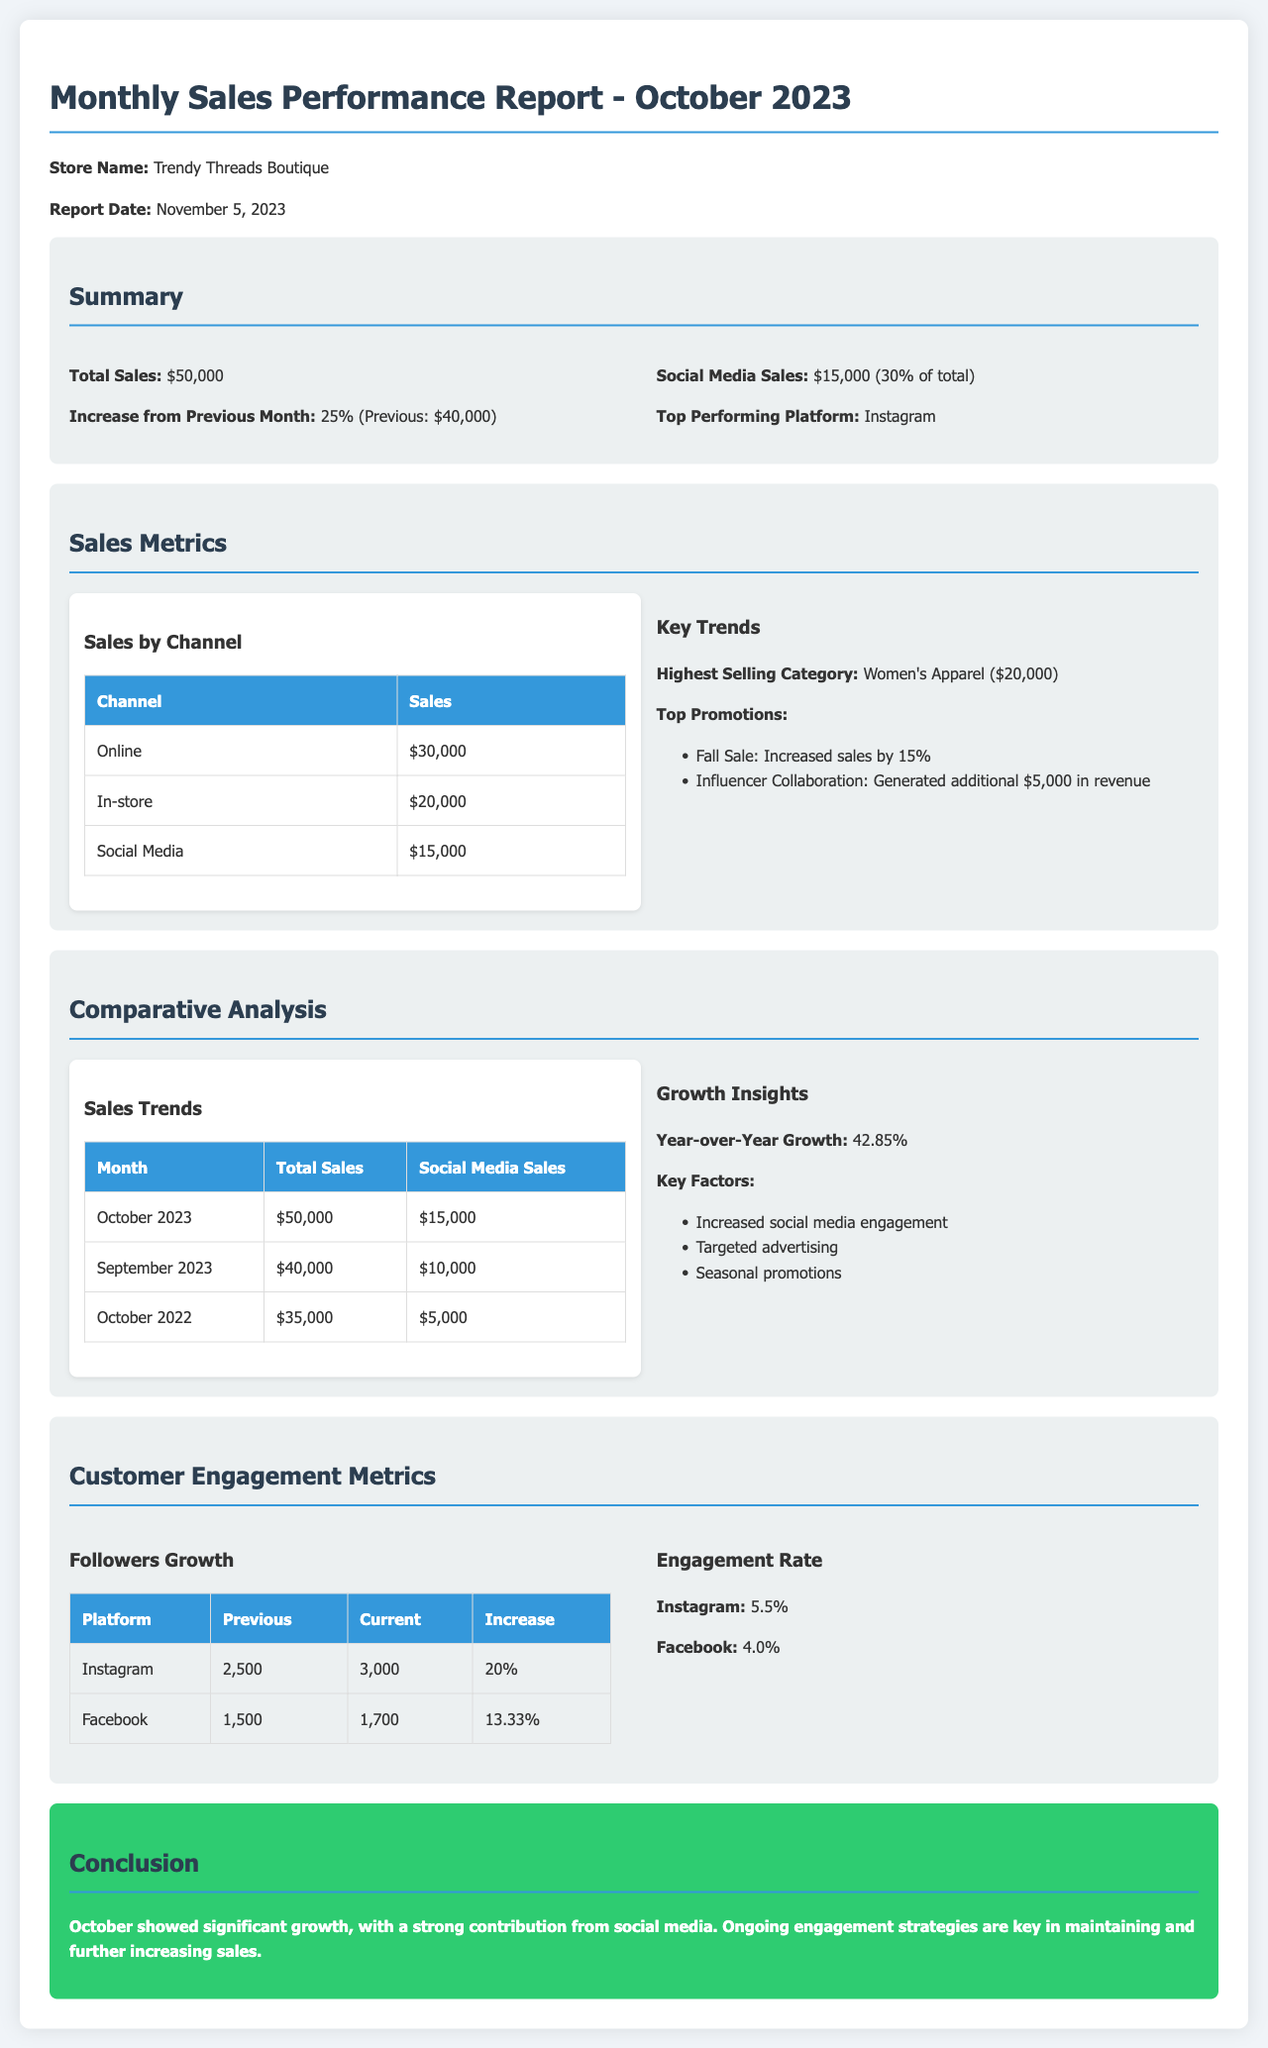what is the total sales for October 2023? The total sales are explicitly stated in the summary section as $50,000.
Answer: $50,000 how much did social media contribute to total sales in October 2023? The document specifies that social media sales were $15,000, which is mentioned in the summary section.
Answer: $15,000 what was the increase in total sales from the previous month? The report states that there was a 25% increase from the previous month, which was $40,000.
Answer: 25% which platform was the top performer in social media sales? The report identifies Instagram as the top-performing platform in the summary section.
Answer: Instagram what was the total sales in October 2022? The comparative analysis table states that total sales in October 2022 were $35,000.
Answer: $35,000 what percentage of total sales in October 2023 came from social media? The summary indicates that social media sales contributed 30% of total sales in October 2023.
Answer: 30% by how much did Instagram followers increase? The followers growth table shows an increase from 2,500 to 3,000, which is a 20% increase.
Answer: 20% what was the year-over-year growth in sales? The document specifies that the year-over-year growth was 42.85%.
Answer: 42.85% what were the top two promotions mentioned in the report? The key promotions listed in the report are the Fall Sale and Influencer Collaboration.
Answer: Fall Sale, Influencer Collaboration 